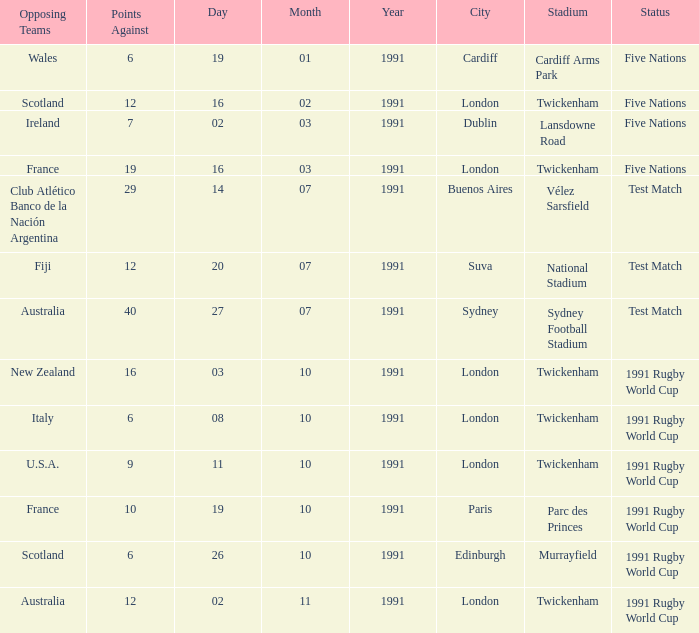What is the opposition, when the opposing team is "australia" and the date is "27/07/1991"? 40.0. 